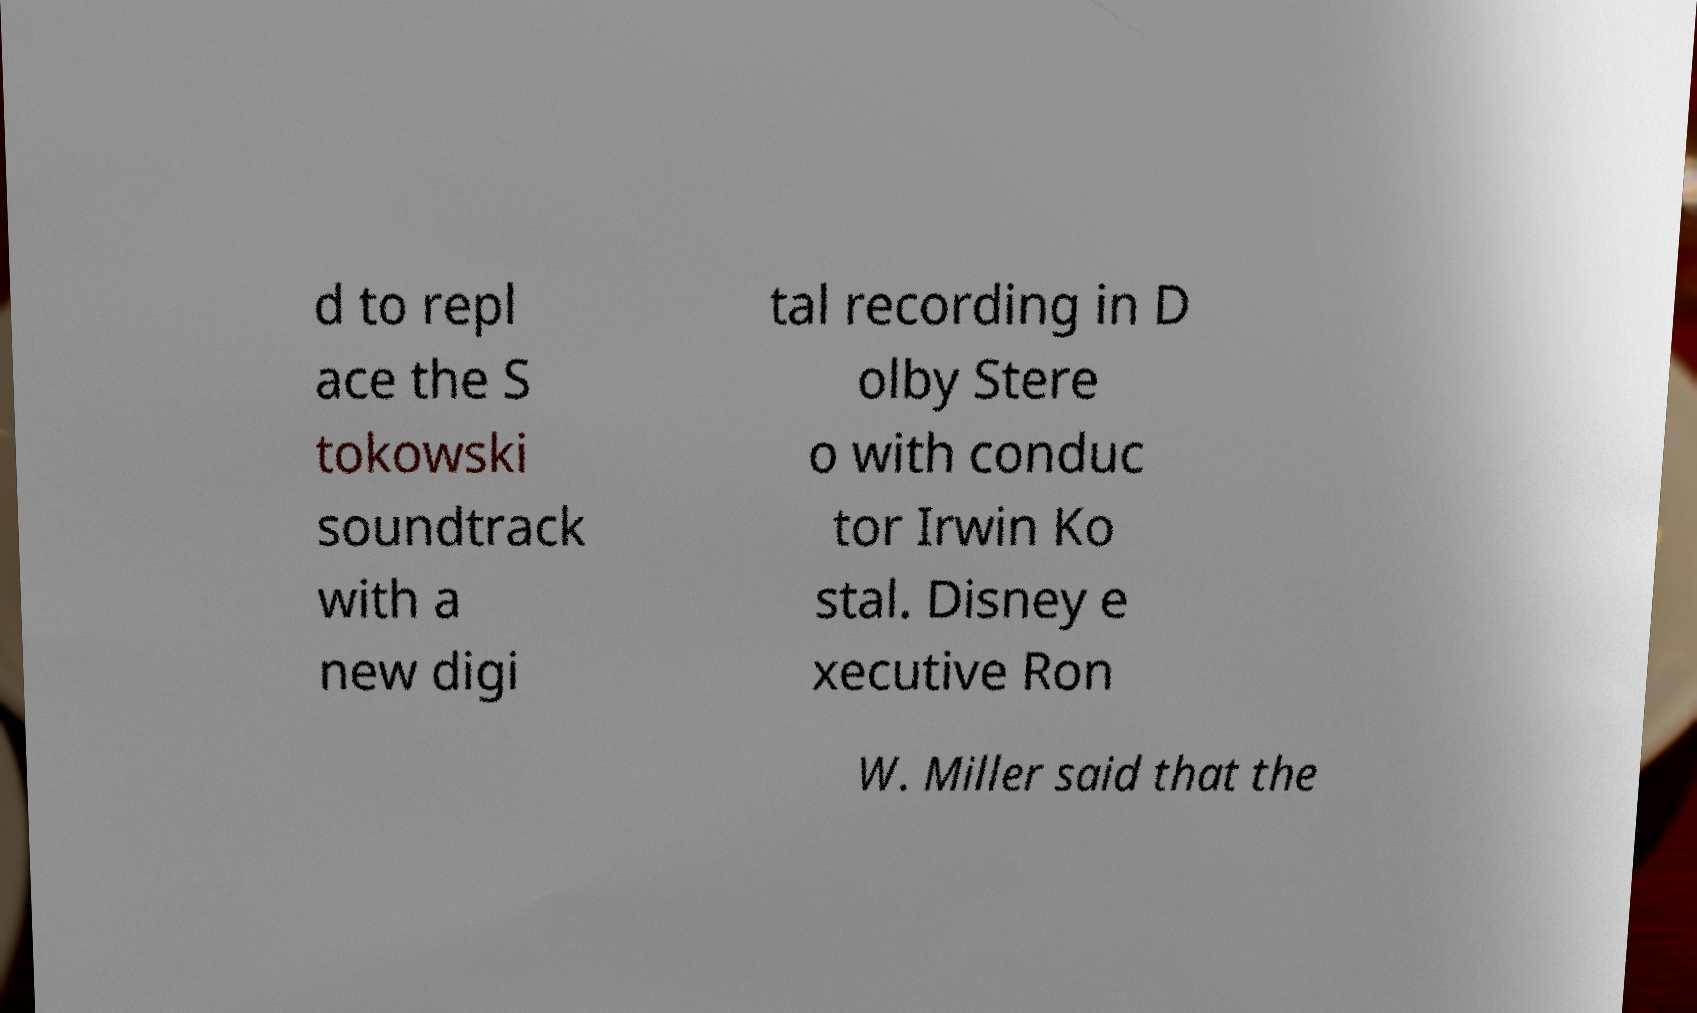Please identify and transcribe the text found in this image. d to repl ace the S tokowski soundtrack with a new digi tal recording in D olby Stere o with conduc tor Irwin Ko stal. Disney e xecutive Ron W. Miller said that the 